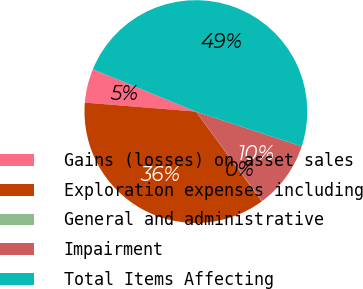<chart> <loc_0><loc_0><loc_500><loc_500><pie_chart><fcel>Gains (losses) on asset sales<fcel>Exploration expenses including<fcel>General and administrative<fcel>Impairment<fcel>Total Items Affecting<nl><fcel>4.92%<fcel>36.38%<fcel>0.04%<fcel>9.8%<fcel>48.86%<nl></chart> 